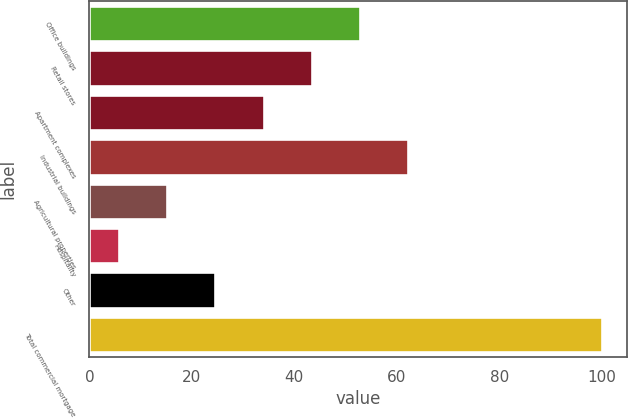Convert chart to OTSL. <chart><loc_0><loc_0><loc_500><loc_500><bar_chart><fcel>Office buildings<fcel>Retail stores<fcel>Apartment complexes<fcel>Industrial buildings<fcel>Agricultural properties<fcel>Hospitality<fcel>Other<fcel>Total commercial mortgage<nl><fcel>52.85<fcel>43.42<fcel>33.99<fcel>62.28<fcel>15.13<fcel>5.7<fcel>24.56<fcel>100<nl></chart> 